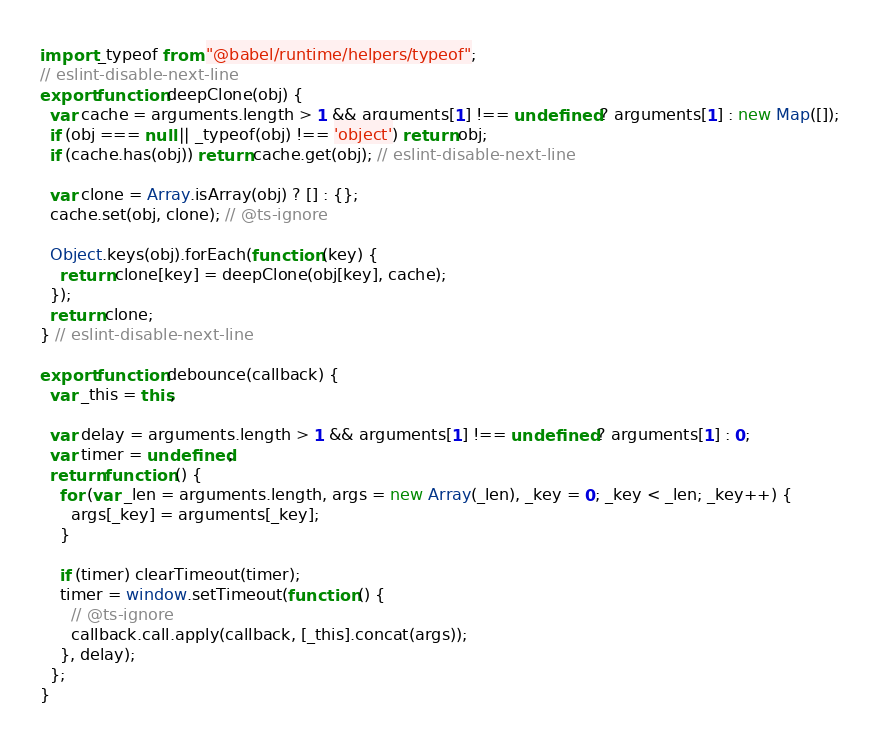<code> <loc_0><loc_0><loc_500><loc_500><_JavaScript_>import _typeof from "@babel/runtime/helpers/typeof";
// eslint-disable-next-line
export function deepClone(obj) {
  var cache = arguments.length > 1 && arguments[1] !== undefined ? arguments[1] : new Map([]);
  if (obj === null || _typeof(obj) !== 'object') return obj;
  if (cache.has(obj)) return cache.get(obj); // eslint-disable-next-line

  var clone = Array.isArray(obj) ? [] : {};
  cache.set(obj, clone); // @ts-ignore

  Object.keys(obj).forEach(function (key) {
    return clone[key] = deepClone(obj[key], cache);
  });
  return clone;
} // eslint-disable-next-line

export function debounce(callback) {
  var _this = this;

  var delay = arguments.length > 1 && arguments[1] !== undefined ? arguments[1] : 0;
  var timer = undefined;
  return function () {
    for (var _len = arguments.length, args = new Array(_len), _key = 0; _key < _len; _key++) {
      args[_key] = arguments[_key];
    }

    if (timer) clearTimeout(timer);
    timer = window.setTimeout(function () {
      // @ts-ignore
      callback.call.apply(callback, [_this].concat(args));
    }, delay);
  };
}</code> 